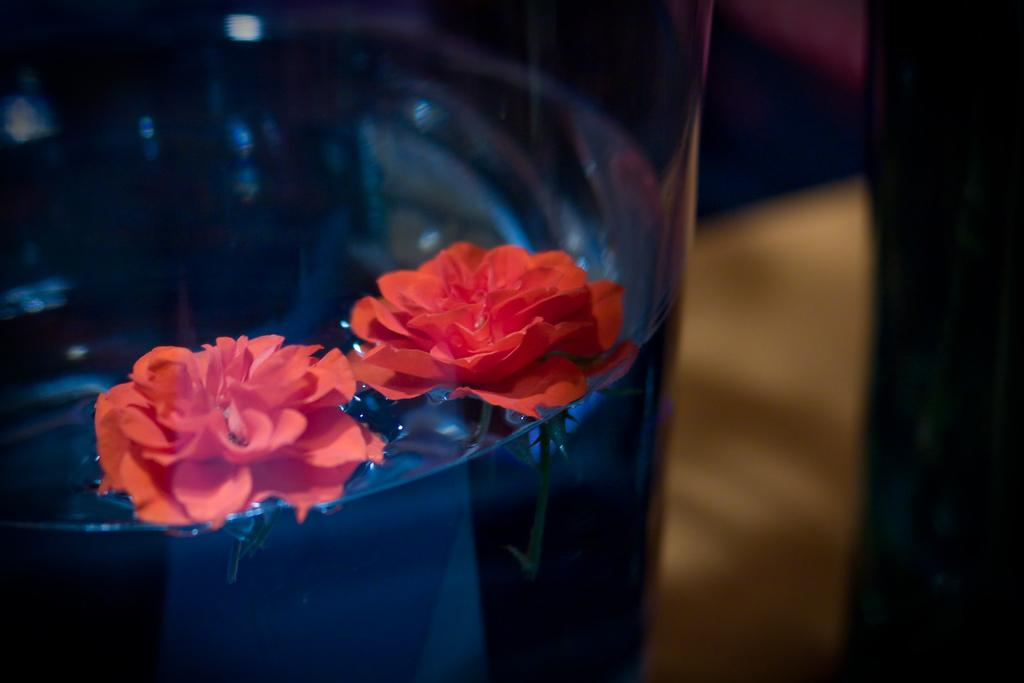What type of flowers are in the glass in the image? There are two rose flowers in the glass in the image. What is the rose flowers resting on in the image? The rose flowers are on water in the image. Can you describe the view on the right side of the image? The view on the right side of the image is blurred. How many wheels can be seen on the edge of the glass in the image? There are no wheels present in the image, as it features rose flowers in a glass with water and a blurred view on the right side. 